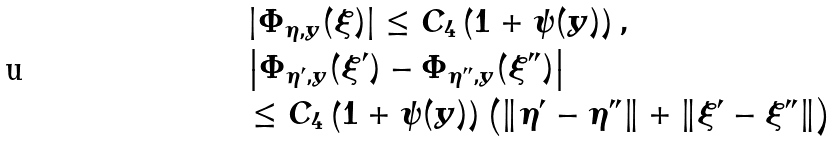Convert formula to latex. <formula><loc_0><loc_0><loc_500><loc_500>& \left | \Phi _ { \eta , y } ( \xi ) \right | \leq C _ { 4 } \left ( 1 + \psi ( y ) \right ) , \\ & \left | \Phi _ { \eta ^ { \prime } , y } ( \xi ^ { \prime } ) - \Phi _ { \eta ^ { \prime \prime } , y } ( \xi ^ { \prime \prime } ) \right | \\ & \leq C _ { 4 } \left ( 1 + \psi ( y ) \right ) \left ( \| \eta ^ { \prime } - \eta ^ { \prime \prime } \| + \| \xi ^ { \prime } - \xi ^ { \prime \prime } \| \right )</formula> 